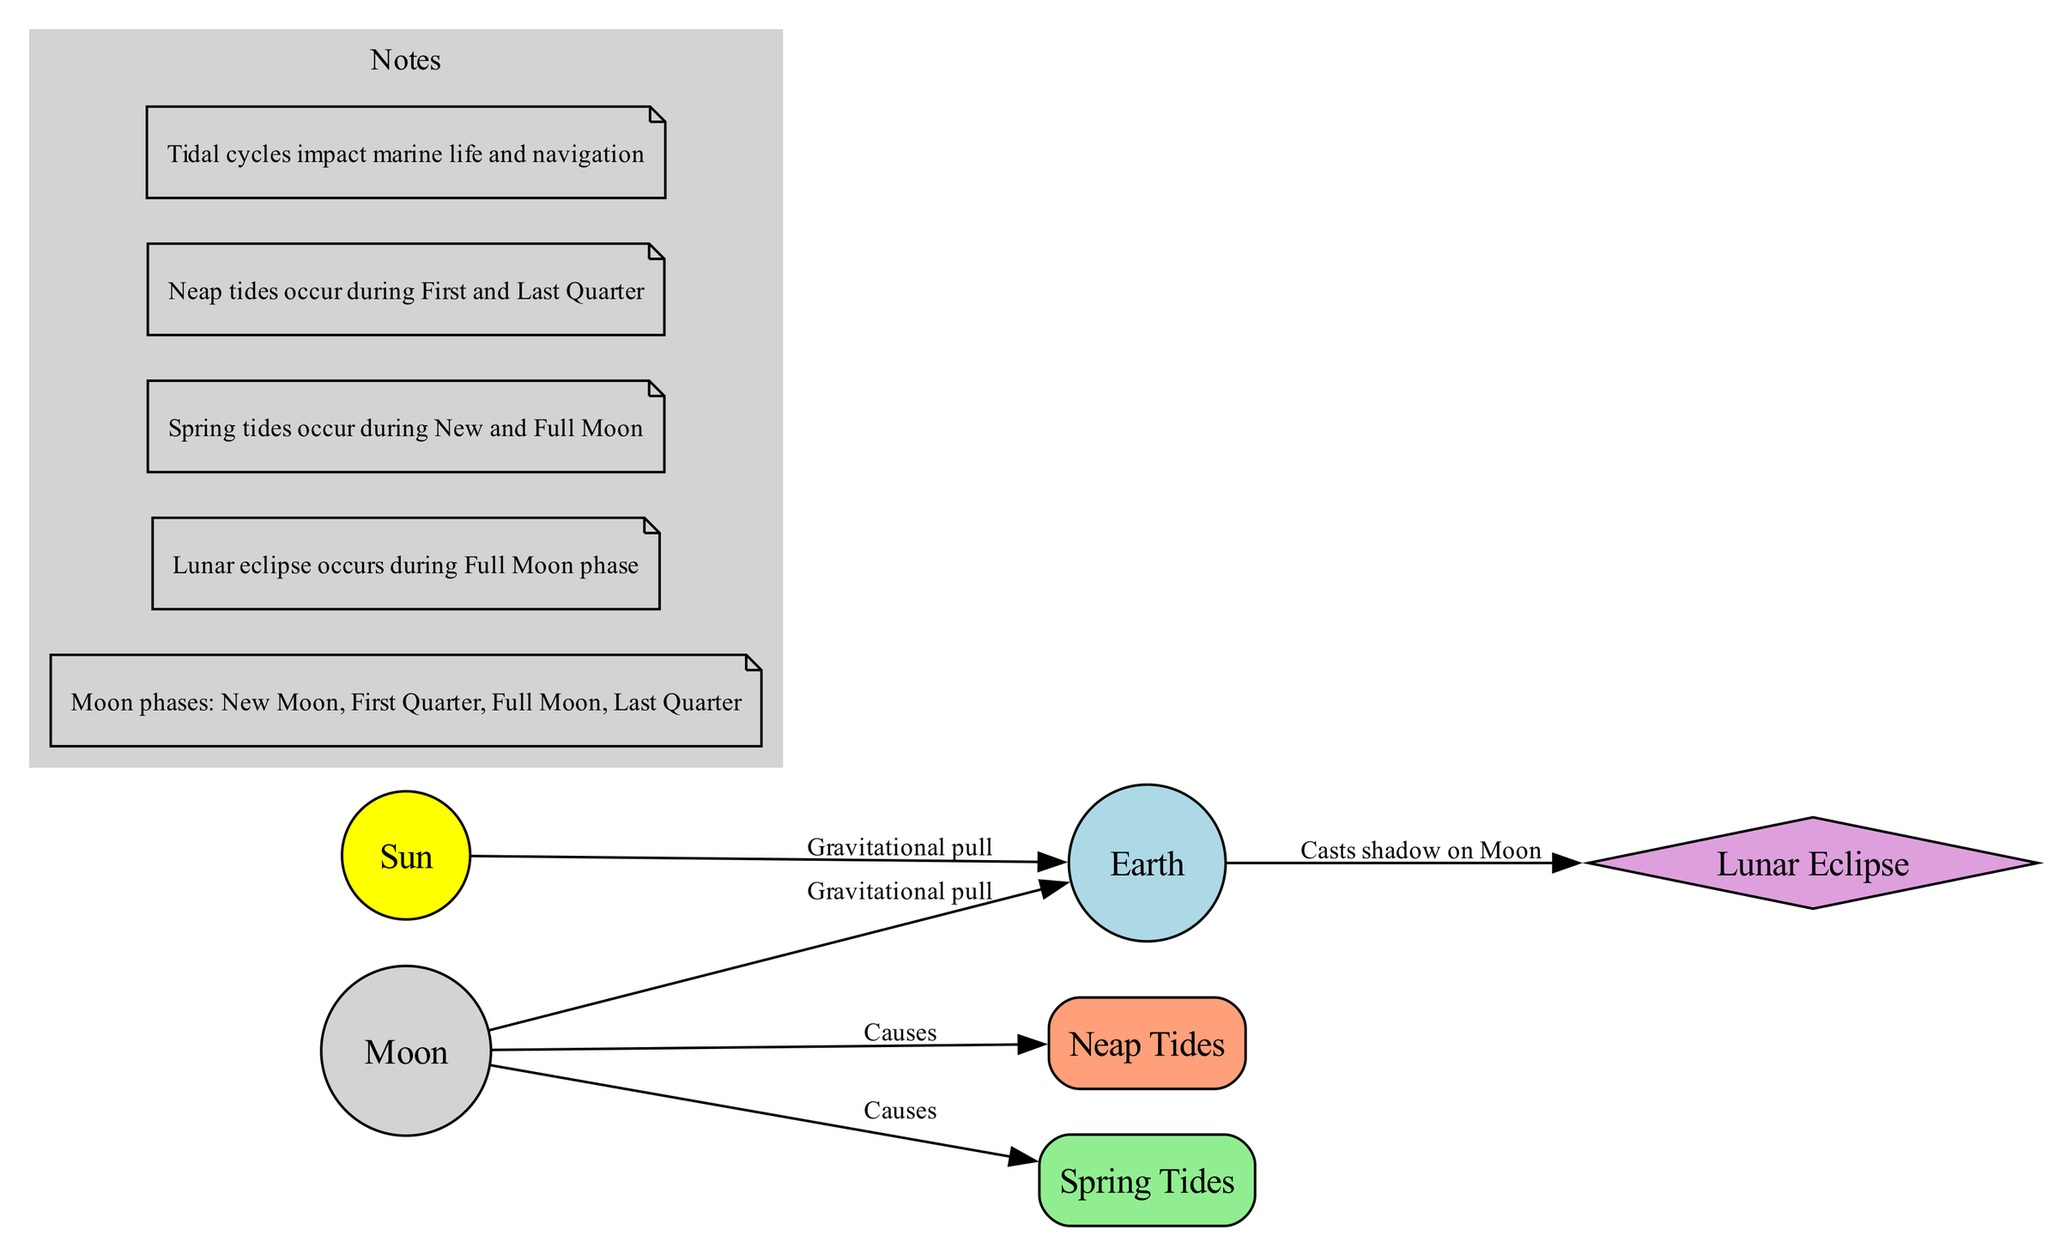What is the relationship between the Moon and Earth? The diagram shows an edge labeled "Gravitational pull" connecting the Moon to Earth. This indicates that the Moon exerts a gravitational force on Earth.
Answer: Gravitational pull How many nodes are present in the diagram? By counting the nodes listed (Moon, Earth, Sun, Neap Tides, Spring Tides, Lunar Eclipse), we find there is a total of six distinct nodes.
Answer: 6 What causes Spring Tides? The diagram has an arrow pointing from the Moon to Spring Tides, labeled "Causes," indicating that the Moon is responsible for Spring Tides.
Answer: Moon During which phase of the Moon does a Lunar Eclipse occur? The notes in the diagram state that a Lunar Eclipse occurs during the Full Moon phase, which identifies this specific phase related to the event.
Answer: Full Moon What type of tides occur during the First Quarter? The notes specify that Neap Tides occur during the First Quarter phase. By recalling the specific phases mentioned, this answer can be derived.
Answer: Neap Tides What physical effect does Earth have on the Moon during a Lunar Eclipse? The diagram illustrates a relationship where Earth "Casts shadow on Moon," indicating the Earth’s shadow falls on the Moon during a Lunar Eclipse.
Answer: Casts shadow What type of tides occur during the New Moon? From the notes, Spring Tides are mentioned to occur during both New and Full Moon phases. Therefore, the answer pertains to the New Moon phase as well.
Answer: Spring Tides 